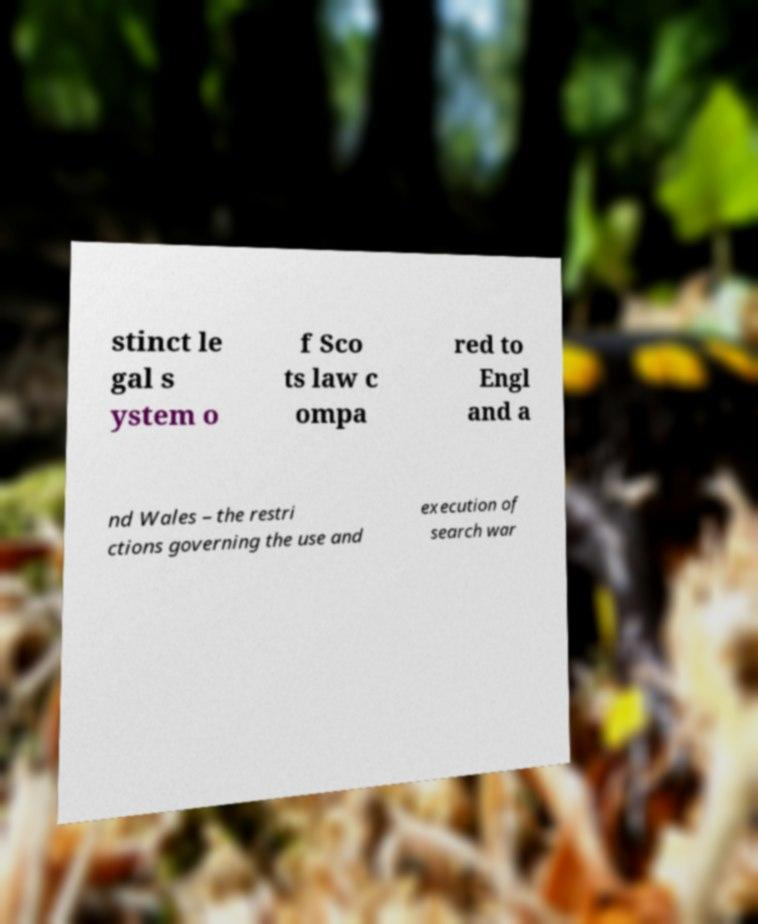There's text embedded in this image that I need extracted. Can you transcribe it verbatim? stinct le gal s ystem o f Sco ts law c ompa red to Engl and a nd Wales – the restri ctions governing the use and execution of search war 